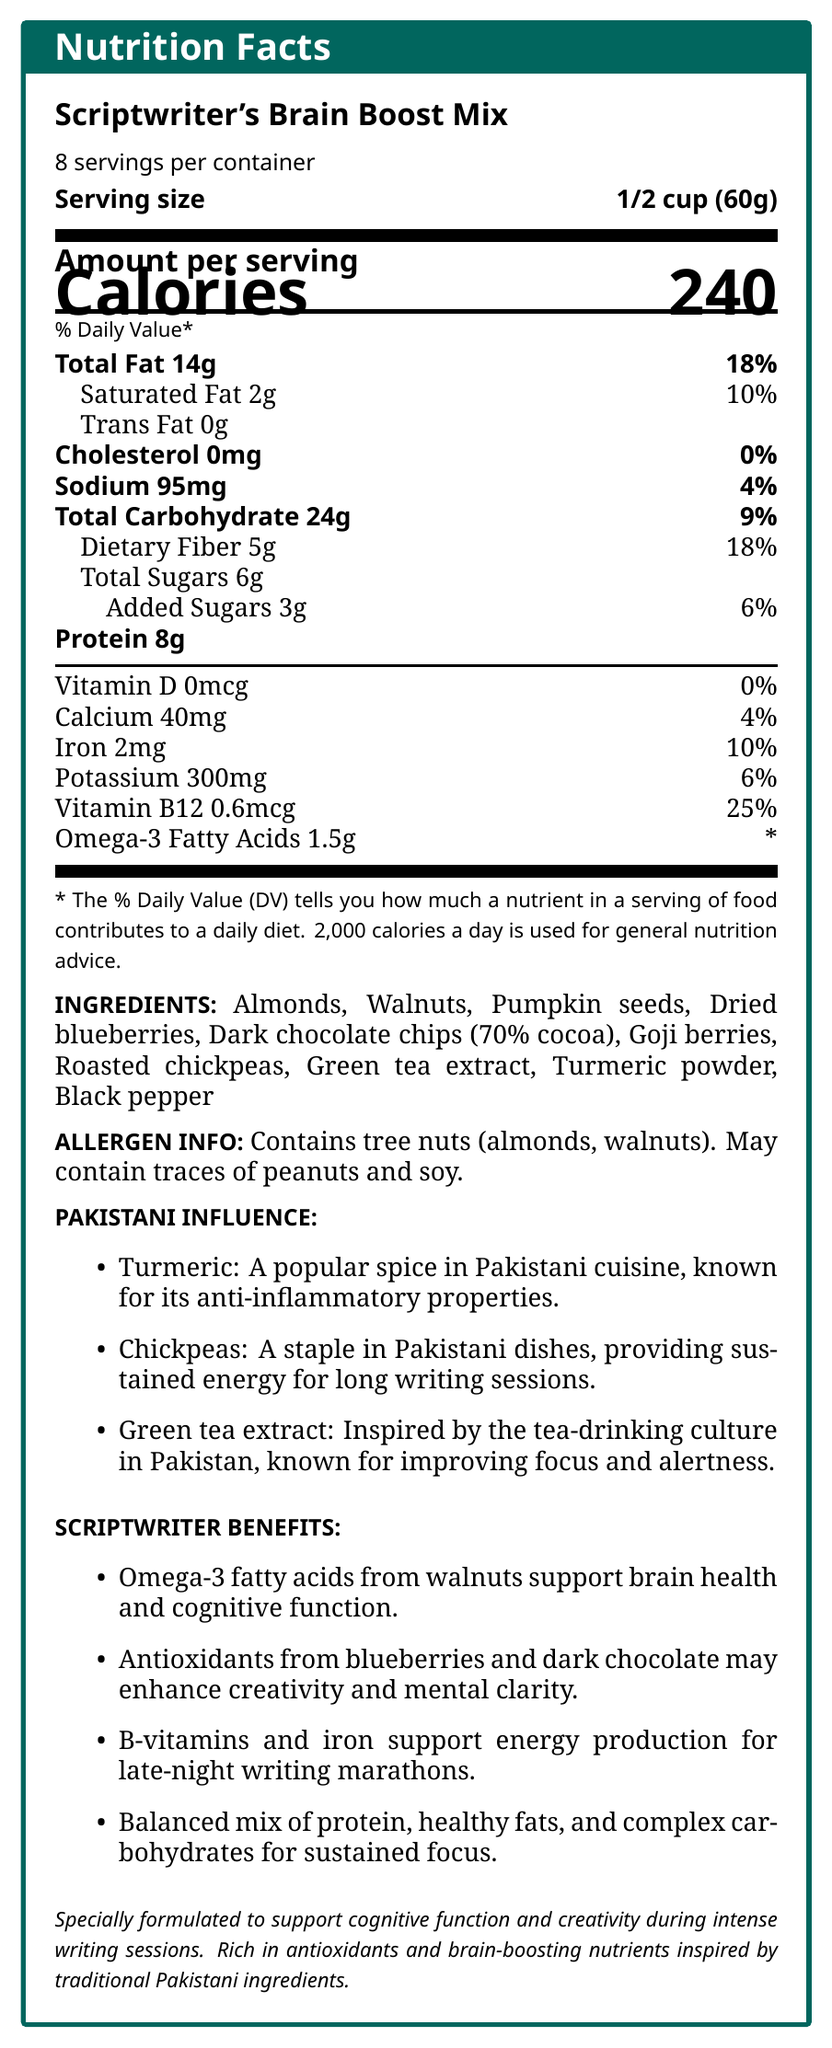how many calories are in one serving of the Scriptwriter's Brain Boost Mix? The nutrition facts label states "Calories 240" as the amount per serving.
Answer: 240 What is the serving size for the Scriptwriter's Brain Boost Mix? The serving size is explicitly mentioned as "1/2 cup (60g)".
Answer: 1/2 cup (60g) How much dietary fiber is in one serving, and what percent of the daily value does it represent? The nutrition facts label lists dietary fiber as 5g and indicates it represents 18% of the daily value.
Answer: 5g, 18% List three ingredients found in the Scriptwriter's Brain Boost Mix. Three ingredients are listed in the ingredients section: Almonds, Walnuts, and Dried blueberries.
Answer: Almonds, Walnuts, Dried blueberries What percent of the daily value for Vitamin B12 does one serving of the snack mix provide? The label shows that Vitamin B12 is 0.6mcg per serving, which is 25% of the daily value.
Answer: 25% Which of the following is not included in the Scriptwriter's Brain Boost Mix? A. Almonds B. Cashews C. Pumpkin seeds D. Goji berries The ingredients list does not include cashews but does include almonds, pumpkin seeds, and goji berries.
Answer: B. Cashews How much iron does one serving of the Scriptwriter's Brain Boost Mix provide? A. 2% B. 6% C. 10% D. 25% The nutrition facts label indicates that one serving provides 2mg of iron, which is 10% of the daily value.
Answer: C. 10% Does the Scriptwriter's Brain Boost Mix contain any cholesterol? The nutrition facts label lists cholesterol as 0mg, indicating there is no cholesterol in the mix.
Answer: No Summarize the key nutritional benefits of the Scriptwriter's Brain Boost Mix for scriptwriters. The key benefits include cognitive support, creativity enhancement, energy production, and sustained focus due to its rich content of omega-3 fatty acids, antioxidants, B-vitamins, and iron. The mix also incorporates traditional Pakistani ingredients known for their health benefits.
Answer: The Scriptwriter's Brain Boost Mix is specially formulated to support cognitive function and creativity during intense writing sessions. It is high in omega-3 fatty acids, antioxidants, B-vitamins, and iron, which together support brain health, mental clarity, energy production, and sustained focus. Additionally, it includes Pakistani-inspired ingredients such as turmeric, chickpeas, and green tea extract, which offer anti-inflammatory properties and improved focus. What nutrients in the Scriptwriter's Brain Boost Mix support brain health and cognitive function? Omega-3 fatty acids from walnuts and B-vitamins, particularly Vitamin B12, support brain health and cognitive function.
Answer: Omega-3 fatty acids and B-vitamins Can you determine the exact proportion of each ingredient in the snack mix? The document lists the ingredients but does not provide the exact proportions or quantities of each.
Answer: Not enough information 